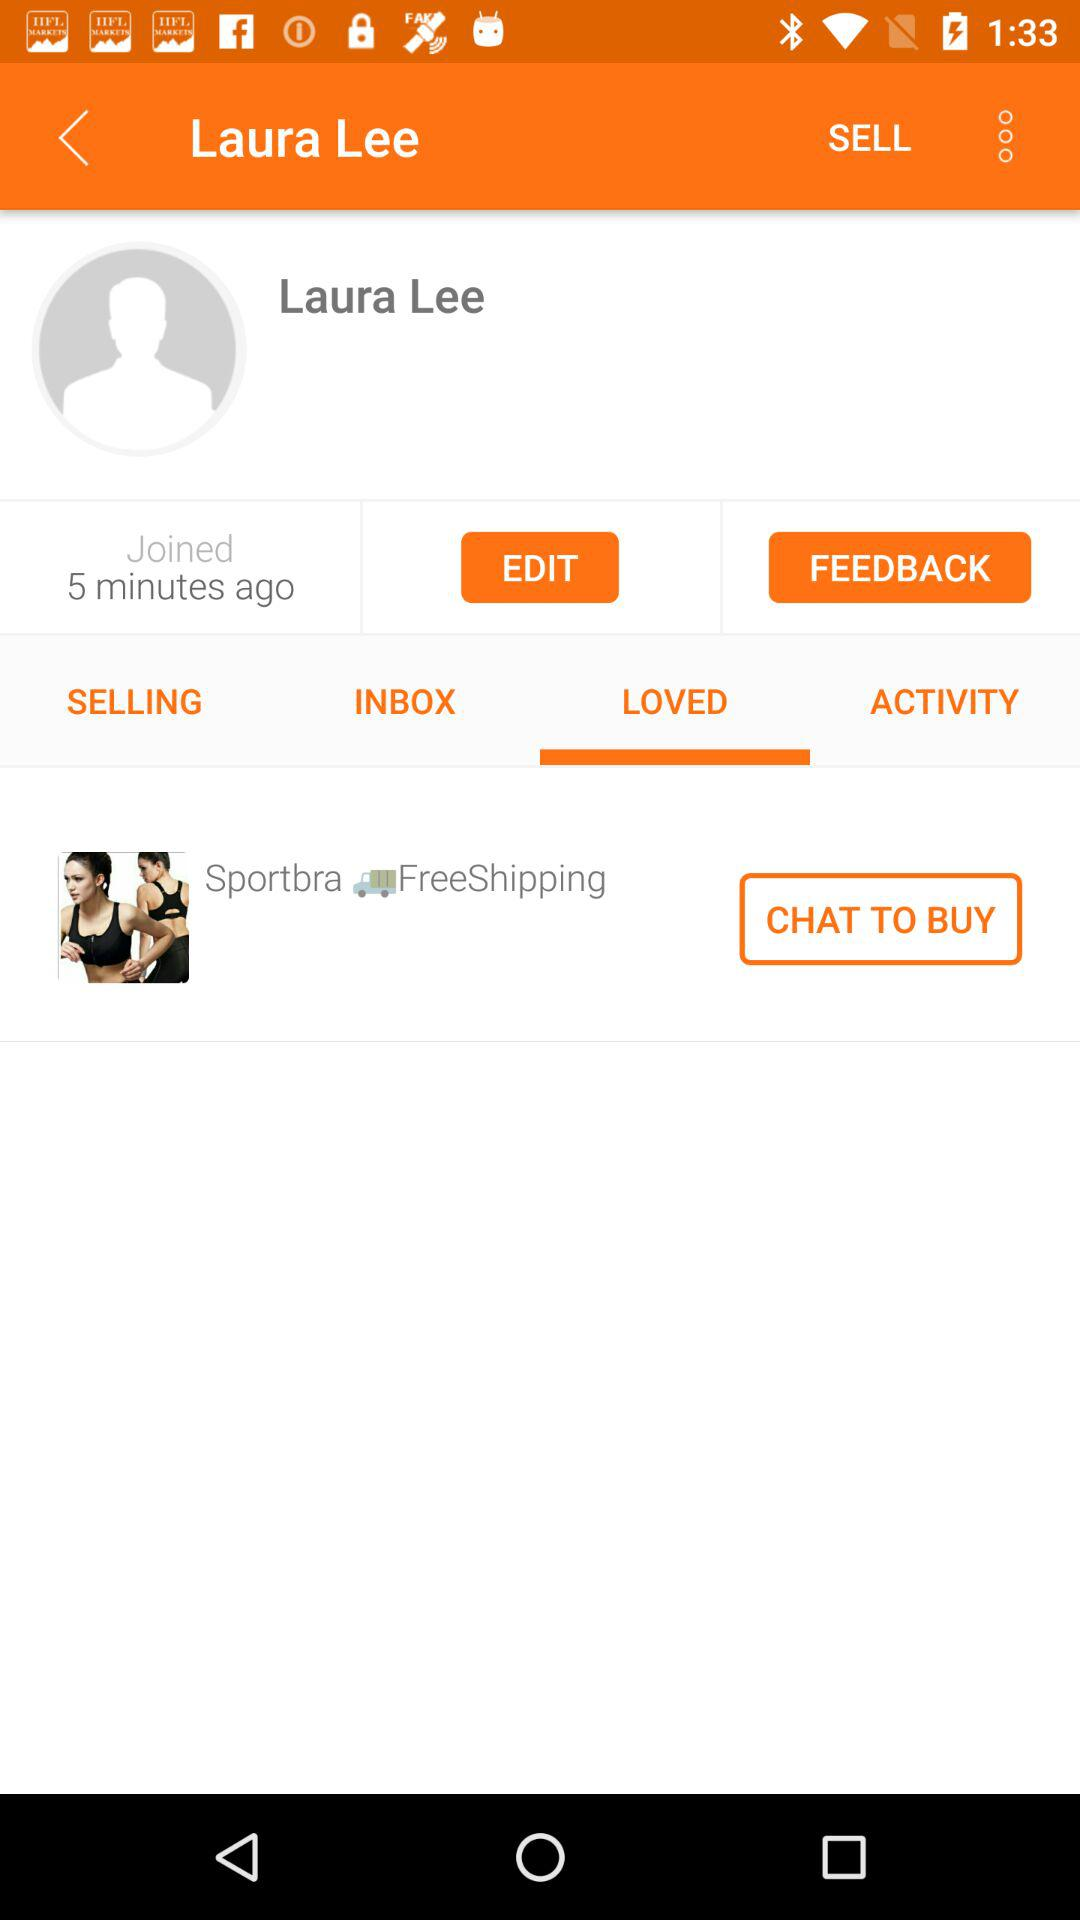What is the name of the user? The name of the user is Laura Lee. 